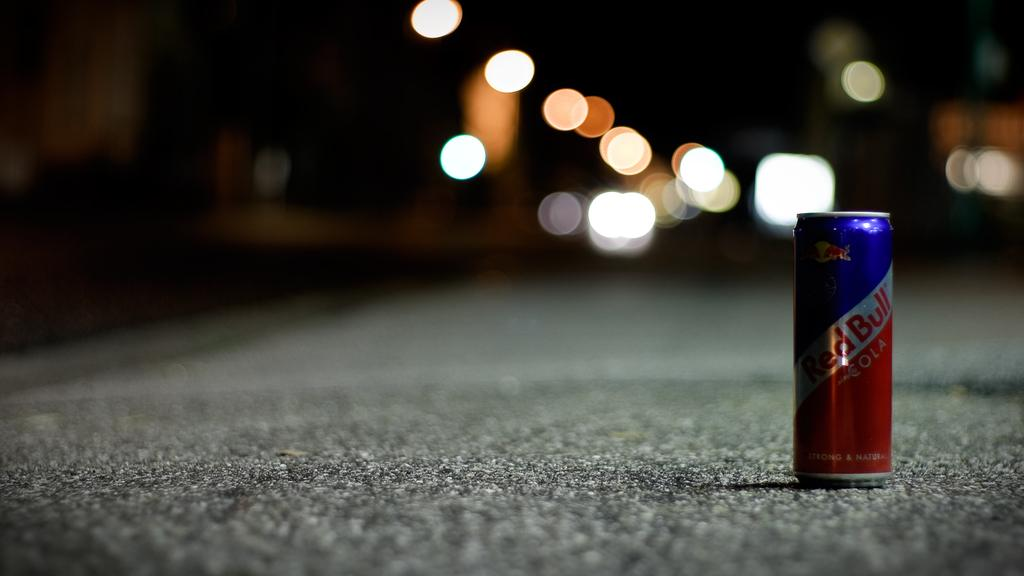<image>
Summarize the visual content of the image. A can of RED BULL sits on an empty street during the nigh 